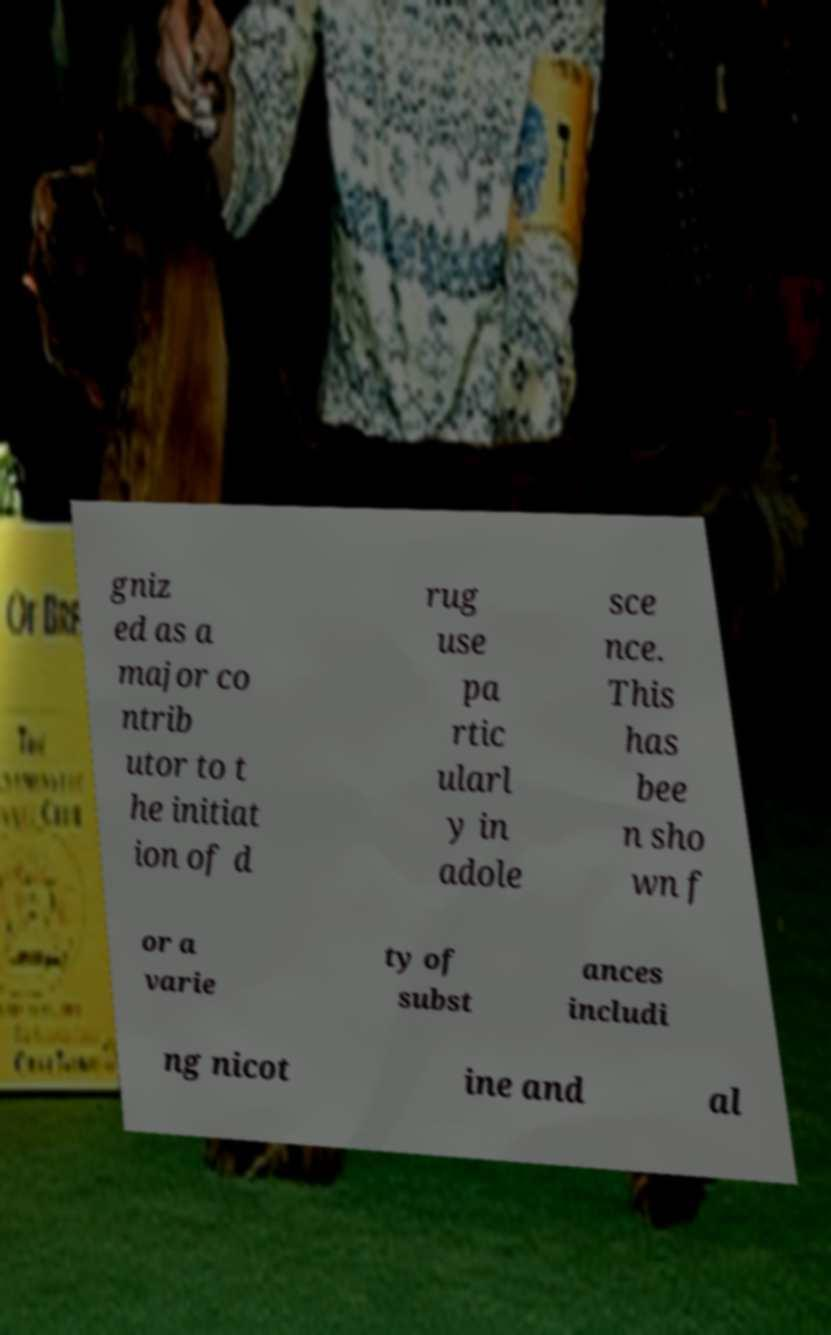There's text embedded in this image that I need extracted. Can you transcribe it verbatim? gniz ed as a major co ntrib utor to t he initiat ion of d rug use pa rtic ularl y in adole sce nce. This has bee n sho wn f or a varie ty of subst ances includi ng nicot ine and al 